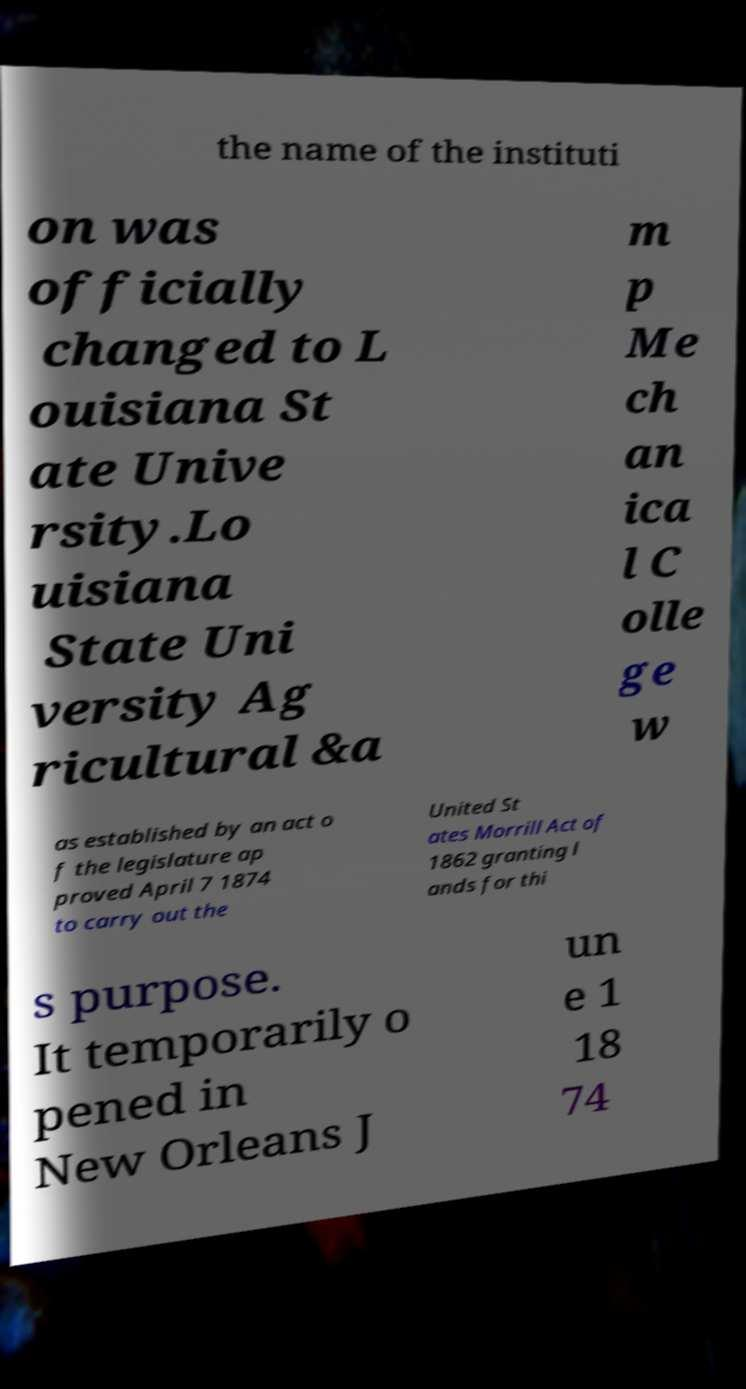There's text embedded in this image that I need extracted. Can you transcribe it verbatim? the name of the instituti on was officially changed to L ouisiana St ate Unive rsity.Lo uisiana State Uni versity Ag ricultural &a m p Me ch an ica l C olle ge w as established by an act o f the legislature ap proved April 7 1874 to carry out the United St ates Morrill Act of 1862 granting l ands for thi s purpose. It temporarily o pened in New Orleans J un e 1 18 74 